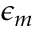<formula> <loc_0><loc_0><loc_500><loc_500>\epsilon _ { m }</formula> 